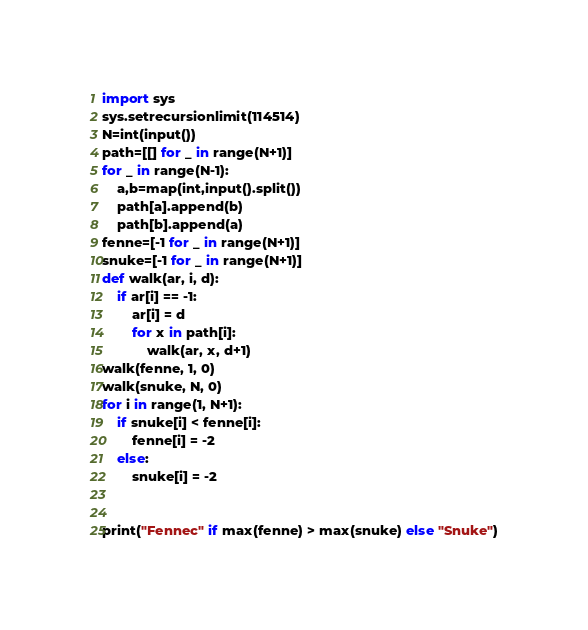Convert code to text. <code><loc_0><loc_0><loc_500><loc_500><_Python_>import sys
sys.setrecursionlimit(114514)
N=int(input())
path=[[] for _ in range(N+1)]
for _ in range(N-1):
	a,b=map(int,input().split())
	path[a].append(b)
	path[b].append(a)
fenne=[-1 for _ in range(N+1)]
snuke=[-1 for _ in range(N+1)]
def walk(ar, i, d):
	if ar[i] == -1:
		ar[i] = d
		for x in path[i]:
			walk(ar, x, d+1)
walk(fenne, 1, 0)
walk(snuke, N, 0)
for i in range(1, N+1):
	if snuke[i] < fenne[i]:
		fenne[i] = -2
	else:
		snuke[i] = -2


print("Fennec" if max(fenne) > max(snuke) else "Snuke")
</code> 